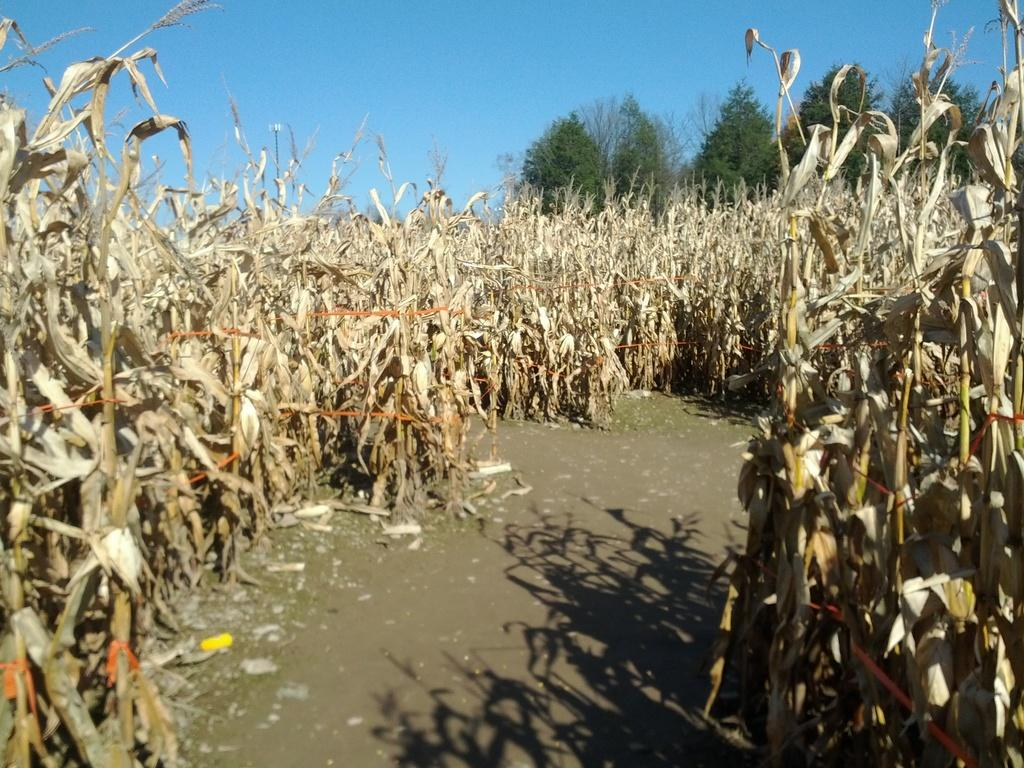What is located in the center of the image? There are dry plants in the center of the image. What can be seen in the background of the image? There are trees in the background of the image. What type of toys can be seen scattered around the dry plants in the image? There are no toys present in the image; it only features dry plants and trees. How quiet is the land depicted in the image? The provided facts do not mention the level of quietness or any sound-related information in the image. 